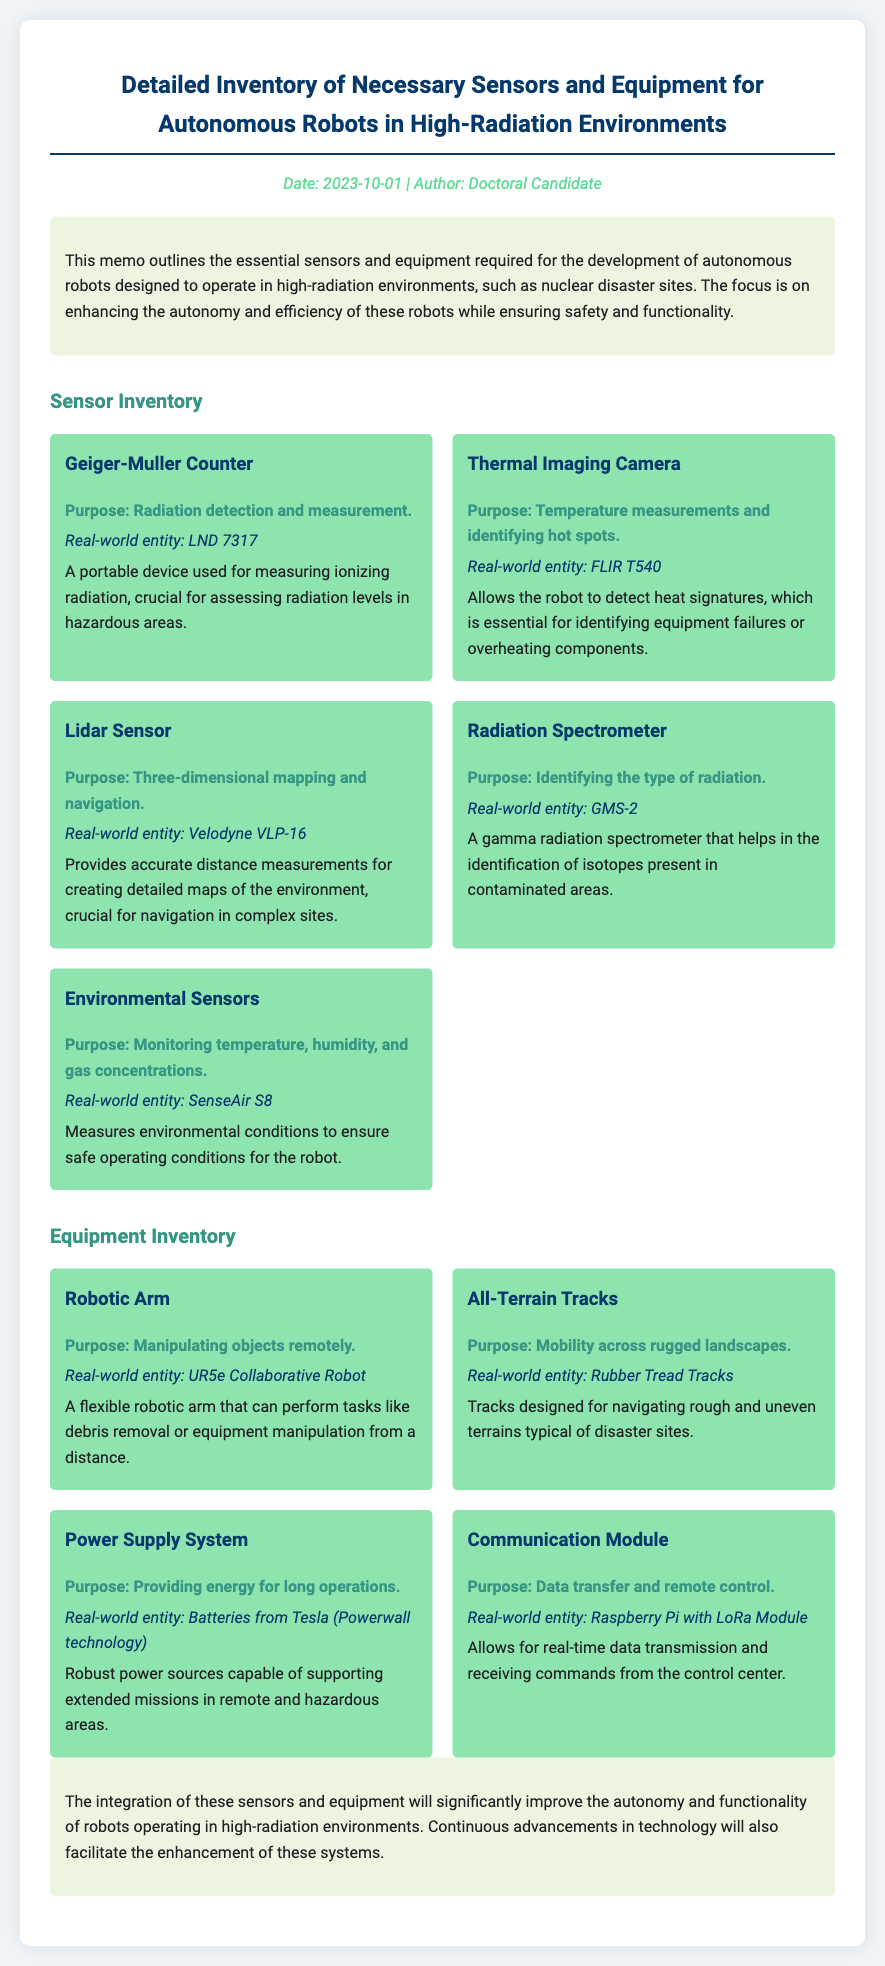What is the date of the memo? The date of the memo is stated in the meta section of the document.
Answer: 2023-10-01 Who is the author of the memo? The author of the memo is mentioned in the same meta section.
Answer: Doctoral Candidate What is the purpose of the Geiger-Muller Counter? The purpose of the Geiger-Muller Counter is described in the Sensor Inventory section.
Answer: Radiation detection and measurement Which real-world entity is associated with the Thermal Imaging Camera? The Thermal Imaging Camera provides its real-world entity in the document.
Answer: FLIR T540 What type of mapping does the Lidar Sensor provide? The type of mapping provided by the Lidar Sensor is noted in the description under the Sensor Inventory.
Answer: Three-dimensional mapping What is the purpose of the Robotic Arm? The purpose of the Robotic Arm is listed in the Equipment Inventory section of the memo.
Answer: Manipulating objects remotely How do All-Terrain Tracks assist autonomous robots? The All-Terrain Tracks assist robots as described in the Equipment Inventory.
Answer: Mobility across rugged landscapes What technology is mentioned for the Power Supply System? The document specifies the technology used in the Power Supply System.
Answer: Powerwall technology What is emphasized in the conclusion of the memo? The conclusion of the memo highlights the impact of sensor and equipment integration.
Answer: Improve autonomy and functionality 